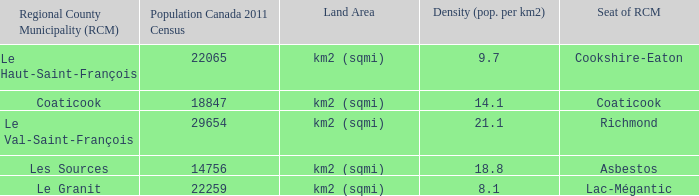What is the seat of the RCM in the county that has a density of 9.7? Cookshire-Eaton. 